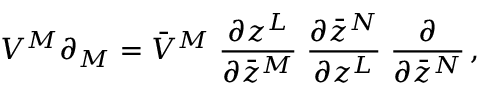Convert formula to latex. <formula><loc_0><loc_0><loc_500><loc_500>V ^ { M } \partial _ { M } = \bar { V } ^ { M } \, \frac { \partial z ^ { L } } { \partial \bar { z } ^ { M } } \, \frac { \partial \bar { z } ^ { N } } { \partial z ^ { L } } \, \frac { \partial } { \partial \bar { z } ^ { N } } \, ,</formula> 